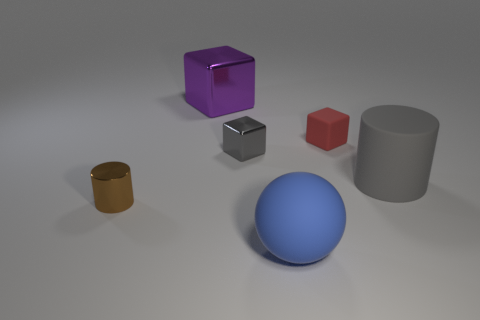Subtract all matte cubes. How many cubes are left? 2 Add 1 matte objects. How many objects exist? 7 Subtract 1 cubes. How many cubes are left? 2 Subtract all cylinders. How many objects are left? 4 Subtract 0 green balls. How many objects are left? 6 Subtract all green cylinders. Subtract all green spheres. How many cylinders are left? 2 Subtract all small green shiny cylinders. Subtract all matte cylinders. How many objects are left? 5 Add 6 shiny things. How many shiny things are left? 9 Add 2 big purple things. How many big purple things exist? 3 